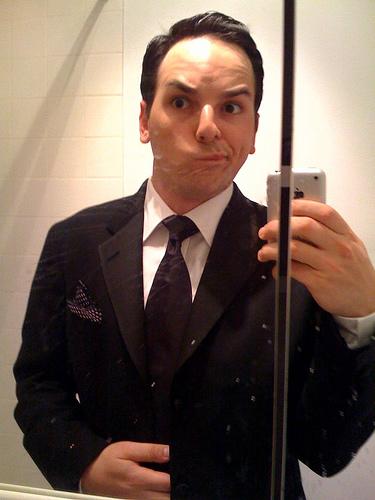What type of picture is this man taking?
Keep it brief. Selfie. What is making the man's fingers to appear to be separated?
Quick response, please. Mirror. What brand is the man's phone?
Concise answer only. Apple. 